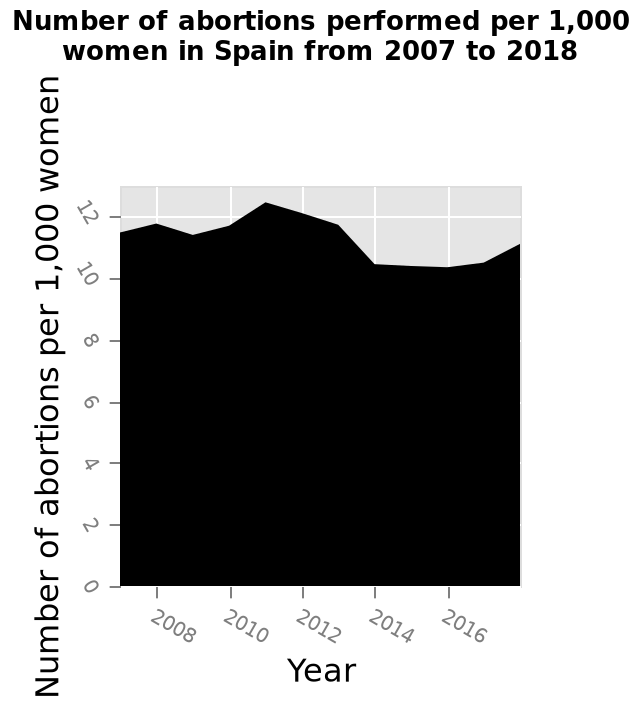<image>
please enumerates aspects of the construction of the chart Here a is a area plot named Number of abortions performed per 1,000 women in Spain from 2007 to 2018. A linear scale of range 2008 to 2016 can be seen on the x-axis, marked Year. Number of abortions per 1,000 women is drawn on the y-axis. What is the title and type of the plot? The title of the plot is "Number of abortions performed per 1,000 women in Spain from 2007 to 2018" and it is an area plot. What is the range of years displayed on the x-axis? The range of years displayed on the x-axis is from 2008 to 2016. 